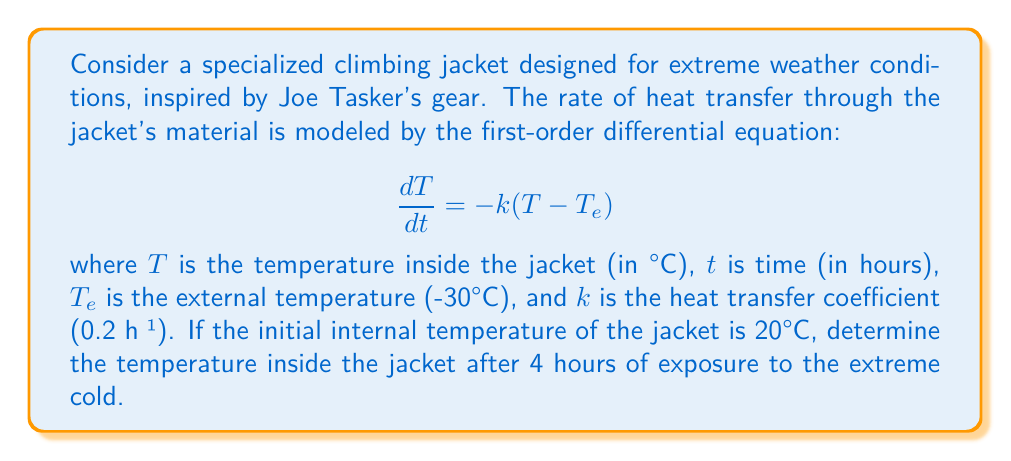Could you help me with this problem? To solve this problem, we need to use the general solution for first-order linear differential equations of the form $\frac{dy}{dx} + P(x)y = Q(x)$.

1. First, we rearrange the given equation to match the standard form:
   $$\frac{dT}{dt} + kT = kT_e$$

2. Identify $P(t) = k = 0.2$ and $Q(t) = kT_e = 0.2(-30) = -6$

3. The general solution for this type of equation is:
   $$T = e^{-\int P(t)dt} \left(\int Q(t)e^{\int P(t)dt}dt + C\right)$$

4. Solve the integrals:
   $\int P(t)dt = \int 0.2 dt = 0.2t$
   $e^{\int P(t)dt} = e^{0.2t}$

5. Substitute into the general solution:
   $$T = e^{-0.2t} \left(\int -6e^{0.2t}dt + C\right)$$

6. Solve the remaining integral:
   $$T = e^{-0.2t} \left(-30e^{0.2t} + C\right) = -30 + Ce^{-0.2t}$$

7. Use the initial condition $T(0) = 20°C$ to find $C$:
   $$20 = -30 + C$$
   $$C = 50$$

8. The particular solution is:
   $$T = -30 + 50e^{-0.2t}$$

9. To find the temperature after 4 hours, substitute $t = 4$:
   $$T(4) = -30 + 50e^{-0.2(4)} = -30 + 50e^{-0.8} \approx -4.97°C$$
Answer: The temperature inside the jacket after 4 hours of exposure to the extreme cold is approximately -4.97°C. 